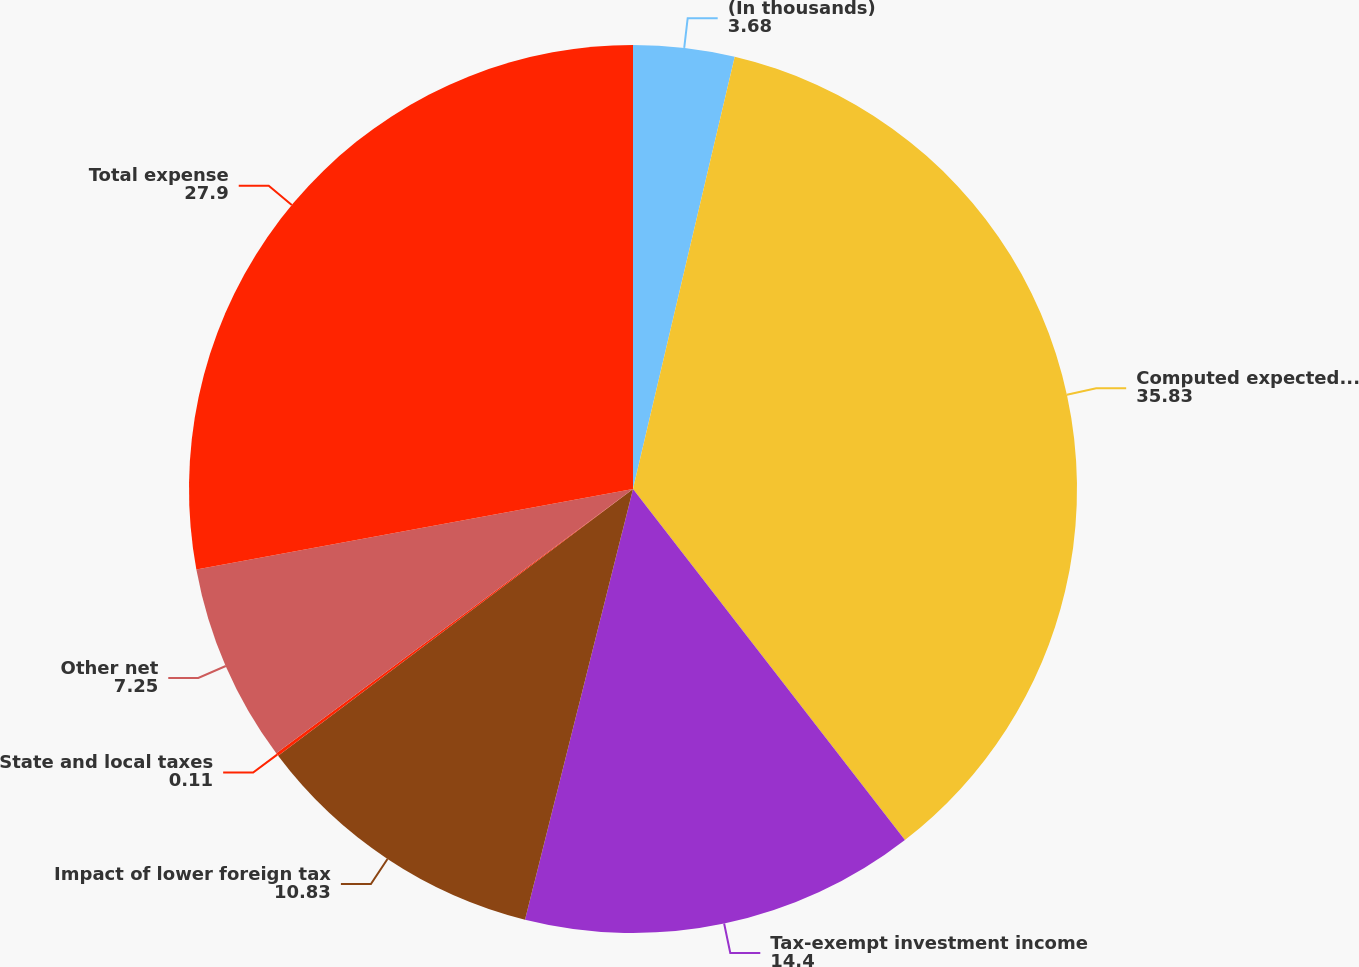Convert chart. <chart><loc_0><loc_0><loc_500><loc_500><pie_chart><fcel>(In thousands)<fcel>Computed expected tax expense<fcel>Tax-exempt investment income<fcel>Impact of lower foreign tax<fcel>State and local taxes<fcel>Other net<fcel>Total expense<nl><fcel>3.68%<fcel>35.83%<fcel>14.4%<fcel>10.83%<fcel>0.11%<fcel>7.25%<fcel>27.9%<nl></chart> 